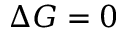<formula> <loc_0><loc_0><loc_500><loc_500>\Delta G = 0</formula> 